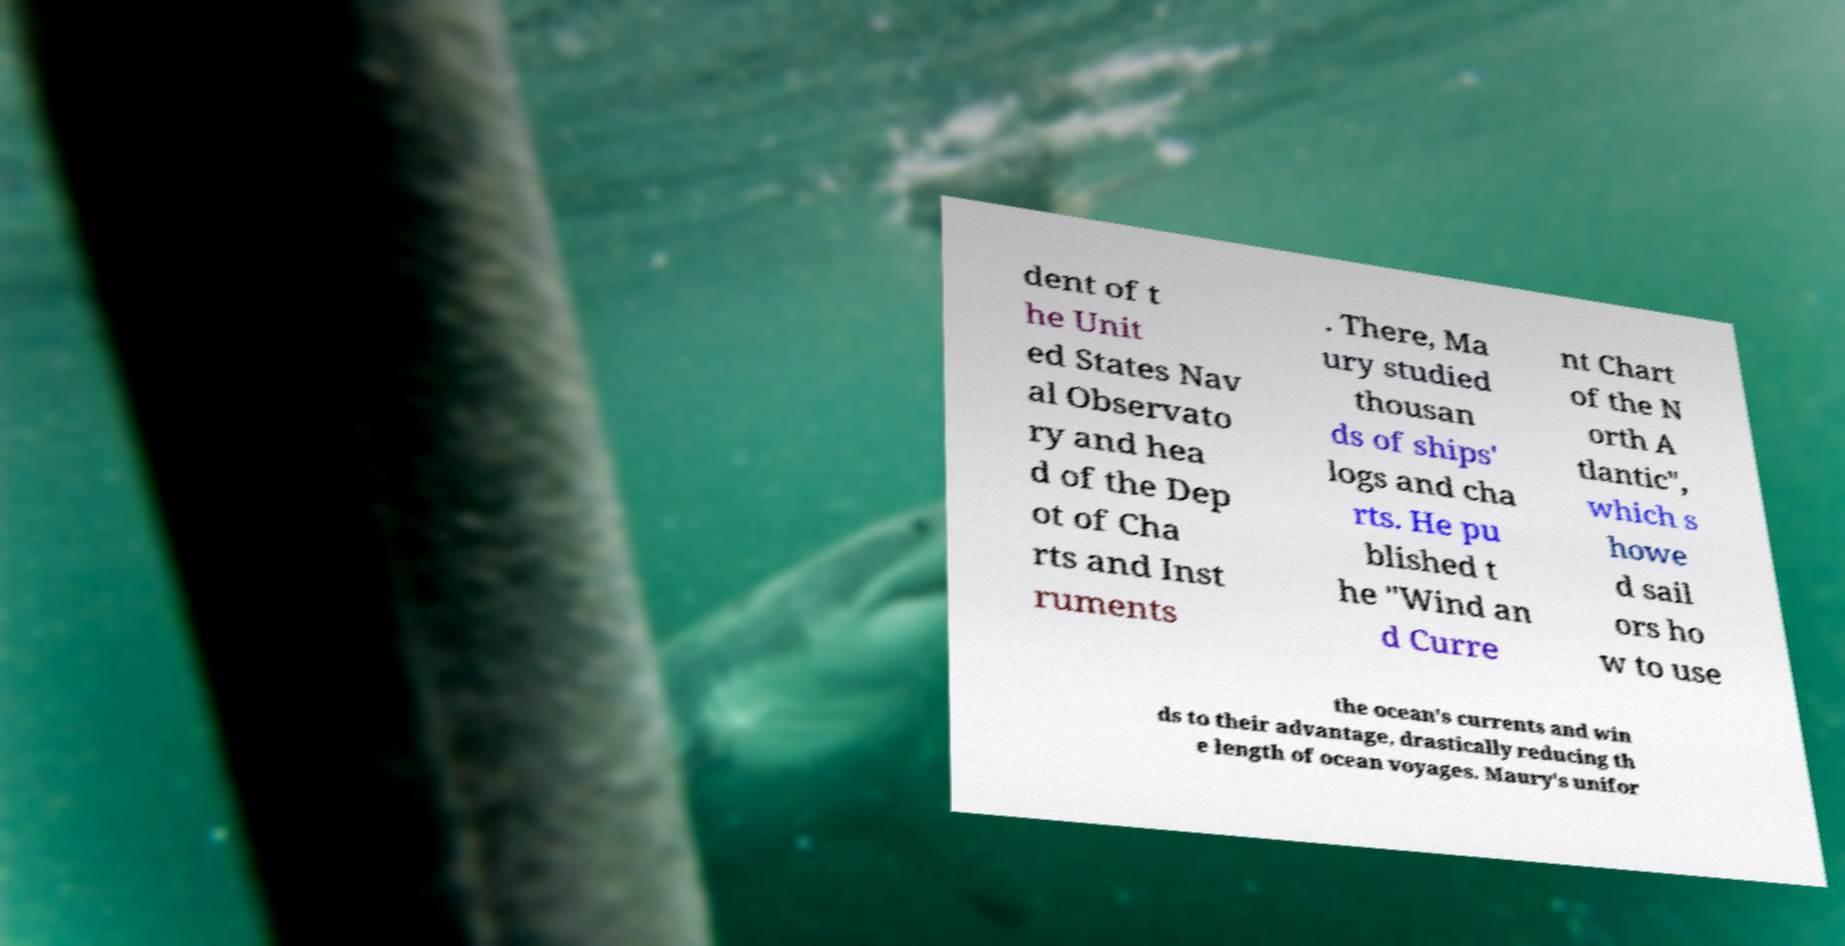There's text embedded in this image that I need extracted. Can you transcribe it verbatim? dent of t he Unit ed States Nav al Observato ry and hea d of the Dep ot of Cha rts and Inst ruments . There, Ma ury studied thousan ds of ships' logs and cha rts. He pu blished t he "Wind an d Curre nt Chart of the N orth A tlantic", which s howe d sail ors ho w to use the ocean's currents and win ds to their advantage, drastically reducing th e length of ocean voyages. Maury's unifor 